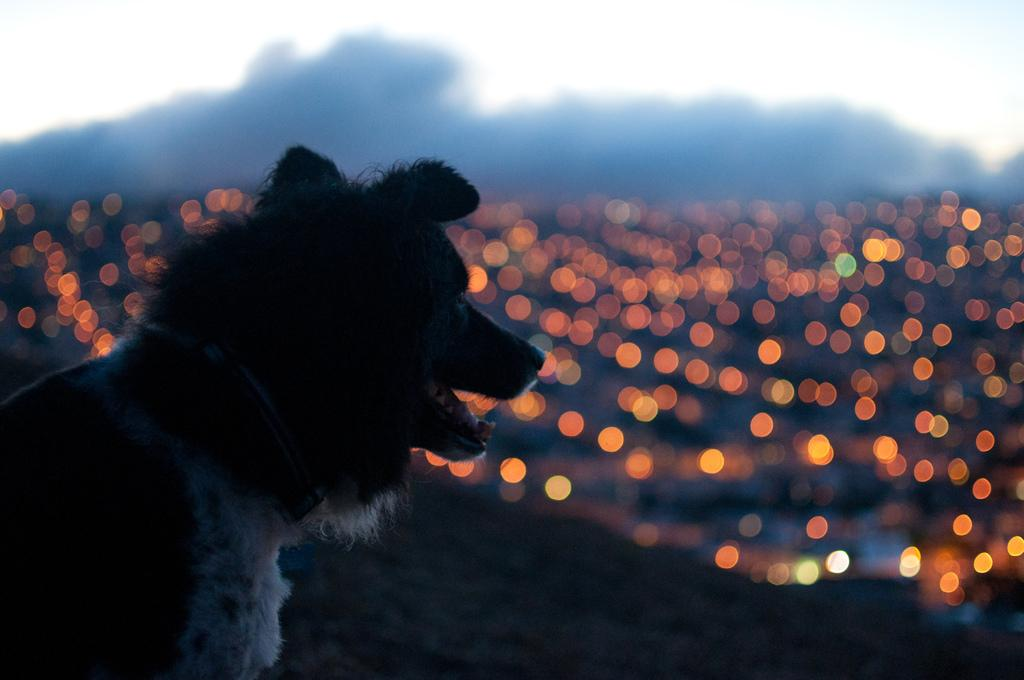What type of animal is in the image? There is a dog in the image. How would you describe the background of the image? The background of the image is blurred. Can you see any light in the background of the image? Yes, there is light visible in the background of the image. What type of door can be seen in the image? There is no door present in the image; it features a dog and a blurred background. How does the dog make a connection with the viewer in the image? The dog does not make a connection with the viewer in the image; it is simply a subject in the photograph. 